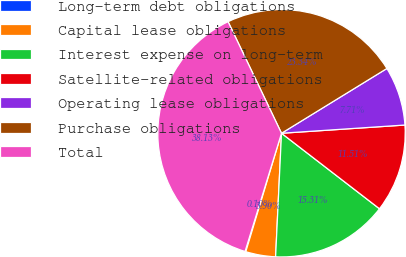Convert chart to OTSL. <chart><loc_0><loc_0><loc_500><loc_500><pie_chart><fcel>Long-term debt obligations<fcel>Capital lease obligations<fcel>Interest expense on long-term<fcel>Satellite-related obligations<fcel>Operating lease obligations<fcel>Purchase obligations<fcel>Total<nl><fcel>0.1%<fcel>3.9%<fcel>15.31%<fcel>11.51%<fcel>7.71%<fcel>23.34%<fcel>38.13%<nl></chart> 